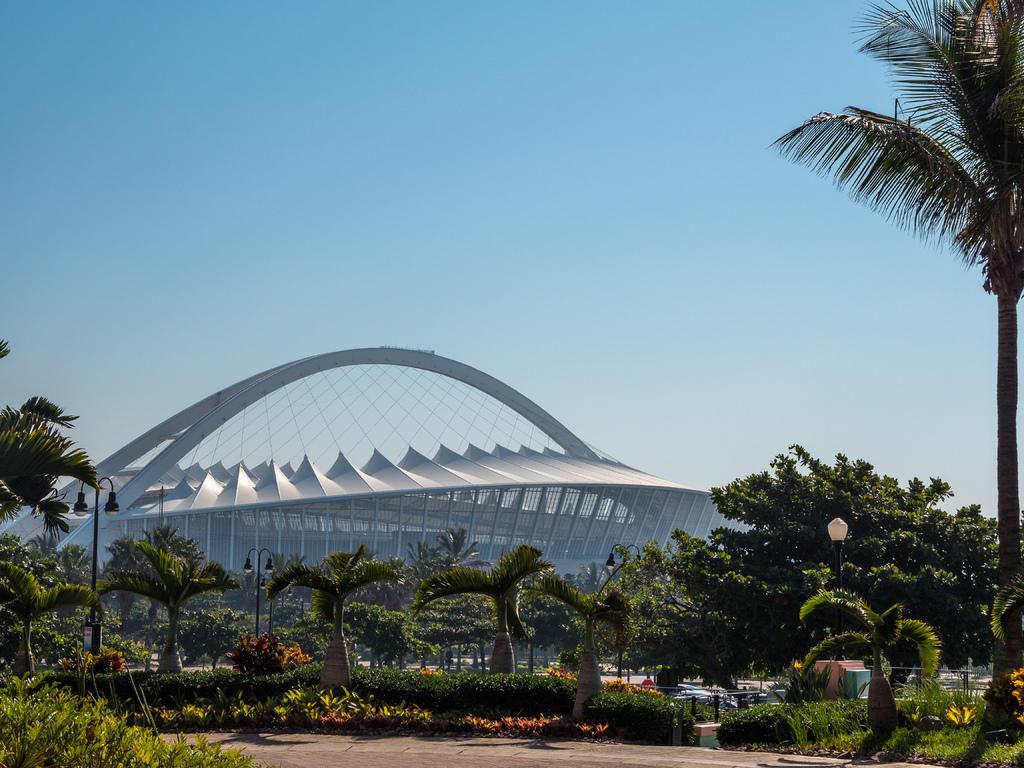Could you give a brief overview of what you see in this image? In this picture we can see a few plants in the bottom left. There are some plants and trees from left to right. We can see street lights on the right and left side of the image. We can see a stadium in the background. Sky is blue in color. 